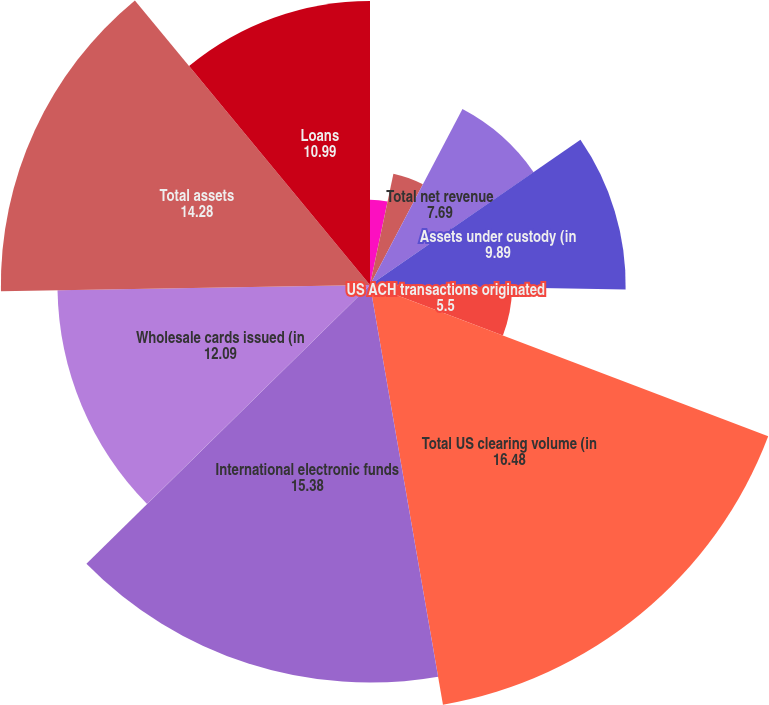Convert chart to OTSL. <chart><loc_0><loc_0><loc_500><loc_500><pie_chart><fcel>Treasury Services<fcel>Worldwide Securities Services<fcel>Total net revenue<fcel>Assets under custody (in<fcel>US ACH transactions originated<fcel>Total US clearing volume (in<fcel>International electronic funds<fcel>Wholesale cards issued (in<fcel>Total assets<fcel>Loans<nl><fcel>3.3%<fcel>4.4%<fcel>7.69%<fcel>9.89%<fcel>5.5%<fcel>16.48%<fcel>15.38%<fcel>12.09%<fcel>14.28%<fcel>10.99%<nl></chart> 